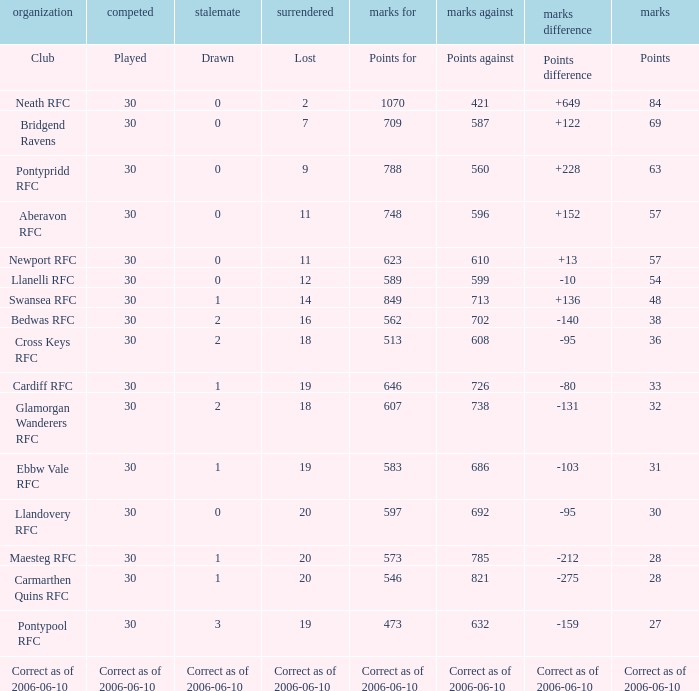What is Lost, when Drawn is "2", and when Points is "36"? 18.0. 